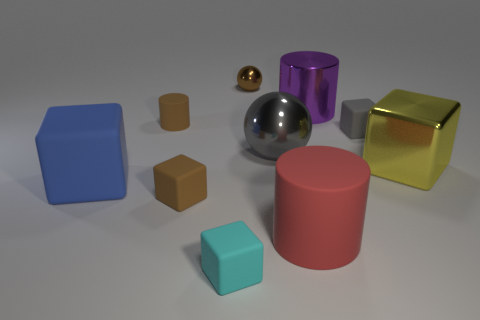There is a small brown cylinder; are there any tiny shiny things on the left side of it?
Make the answer very short. No. How big is the cylinder that is behind the big red cylinder and to the right of the tiny brown cylinder?
Your answer should be very brief. Large. How many things are either cylinders or tiny green rubber things?
Offer a very short reply. 3. Does the shiny cube have the same size as the matte block that is to the right of the small brown metal sphere?
Provide a short and direct response. No. What size is the cylinder behind the cylinder to the left of the tiny rubber cube in front of the red matte thing?
Provide a short and direct response. Large. Is there a big brown thing?
Offer a terse response. No. There is a thing that is the same color as the large shiny sphere; what is it made of?
Provide a short and direct response. Rubber. How many matte objects have the same color as the small sphere?
Ensure brevity in your answer.  2. How many objects are either things behind the large red cylinder or matte cylinders that are left of the big red rubber cylinder?
Ensure brevity in your answer.  8. There is a matte block that is on the right side of the cyan block; how many tiny spheres are behind it?
Your answer should be compact. 1. 